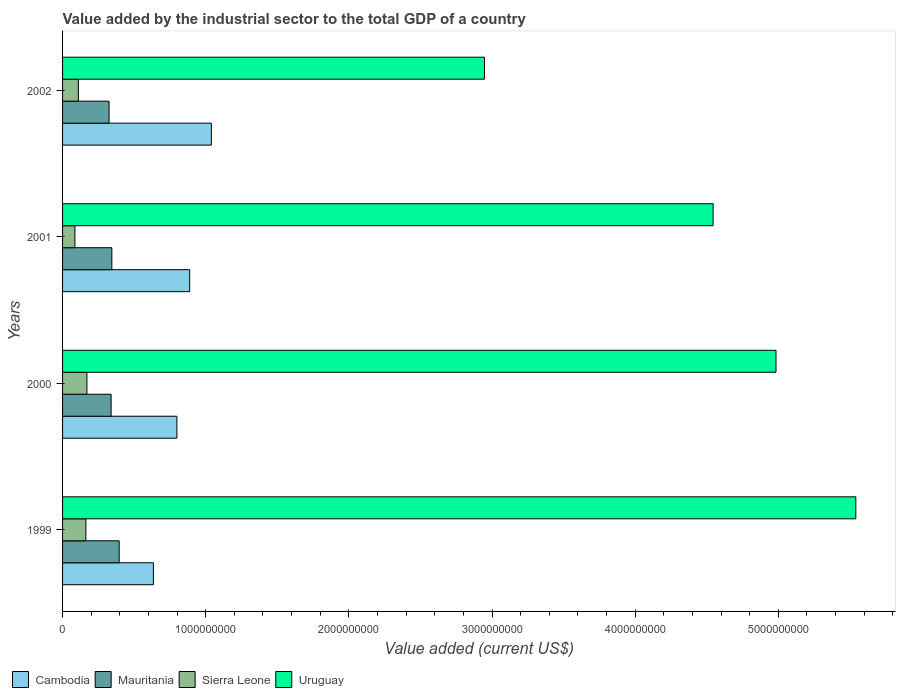How many bars are there on the 3rd tick from the bottom?
Your answer should be compact. 4. What is the label of the 1st group of bars from the top?
Offer a very short reply. 2002. In how many cases, is the number of bars for a given year not equal to the number of legend labels?
Keep it short and to the point. 0. What is the value added by the industrial sector to the total GDP in Sierra Leone in 1999?
Ensure brevity in your answer.  1.63e+08. Across all years, what is the maximum value added by the industrial sector to the total GDP in Cambodia?
Your answer should be compact. 1.04e+09. Across all years, what is the minimum value added by the industrial sector to the total GDP in Cambodia?
Make the answer very short. 6.35e+08. In which year was the value added by the industrial sector to the total GDP in Mauritania minimum?
Keep it short and to the point. 2002. What is the total value added by the industrial sector to the total GDP in Sierra Leone in the graph?
Keep it short and to the point. 5.29e+08. What is the difference between the value added by the industrial sector to the total GDP in Mauritania in 1999 and that in 2002?
Ensure brevity in your answer.  7.09e+07. What is the difference between the value added by the industrial sector to the total GDP in Mauritania in 1999 and the value added by the industrial sector to the total GDP in Uruguay in 2002?
Make the answer very short. -2.55e+09. What is the average value added by the industrial sector to the total GDP in Sierra Leone per year?
Offer a terse response. 1.32e+08. In the year 2002, what is the difference between the value added by the industrial sector to the total GDP in Mauritania and value added by the industrial sector to the total GDP in Uruguay?
Provide a short and direct response. -2.62e+09. What is the ratio of the value added by the industrial sector to the total GDP in Cambodia in 2001 to that in 2002?
Make the answer very short. 0.85. What is the difference between the highest and the second highest value added by the industrial sector to the total GDP in Uruguay?
Your response must be concise. 5.58e+08. What is the difference between the highest and the lowest value added by the industrial sector to the total GDP in Cambodia?
Your response must be concise. 4.05e+08. In how many years, is the value added by the industrial sector to the total GDP in Sierra Leone greater than the average value added by the industrial sector to the total GDP in Sierra Leone taken over all years?
Offer a terse response. 2. What does the 1st bar from the top in 2002 represents?
Your answer should be very brief. Uruguay. What does the 1st bar from the bottom in 2002 represents?
Offer a terse response. Cambodia. Is it the case that in every year, the sum of the value added by the industrial sector to the total GDP in Uruguay and value added by the industrial sector to the total GDP in Mauritania is greater than the value added by the industrial sector to the total GDP in Sierra Leone?
Give a very brief answer. Yes. How many bars are there?
Provide a succinct answer. 16. Are all the bars in the graph horizontal?
Keep it short and to the point. Yes. How many years are there in the graph?
Give a very brief answer. 4. Are the values on the major ticks of X-axis written in scientific E-notation?
Provide a succinct answer. No. Does the graph contain any zero values?
Keep it short and to the point. No. Does the graph contain grids?
Offer a very short reply. No. How are the legend labels stacked?
Your answer should be compact. Horizontal. What is the title of the graph?
Offer a very short reply. Value added by the industrial sector to the total GDP of a country. What is the label or title of the X-axis?
Make the answer very short. Value added (current US$). What is the Value added (current US$) of Cambodia in 1999?
Offer a very short reply. 6.35e+08. What is the Value added (current US$) in Mauritania in 1999?
Your answer should be compact. 3.96e+08. What is the Value added (current US$) of Sierra Leone in 1999?
Offer a very short reply. 1.63e+08. What is the Value added (current US$) in Uruguay in 1999?
Your answer should be very brief. 5.54e+09. What is the Value added (current US$) in Cambodia in 2000?
Offer a terse response. 7.99e+08. What is the Value added (current US$) of Mauritania in 2000?
Your answer should be compact. 3.39e+08. What is the Value added (current US$) of Sierra Leone in 2000?
Offer a very short reply. 1.70e+08. What is the Value added (current US$) in Uruguay in 2000?
Offer a very short reply. 4.98e+09. What is the Value added (current US$) in Cambodia in 2001?
Offer a terse response. 8.88e+08. What is the Value added (current US$) in Mauritania in 2001?
Your answer should be very brief. 3.44e+08. What is the Value added (current US$) in Sierra Leone in 2001?
Provide a short and direct response. 8.62e+07. What is the Value added (current US$) in Uruguay in 2001?
Your answer should be compact. 4.54e+09. What is the Value added (current US$) of Cambodia in 2002?
Offer a terse response. 1.04e+09. What is the Value added (current US$) of Mauritania in 2002?
Your response must be concise. 3.25e+08. What is the Value added (current US$) of Sierra Leone in 2002?
Your response must be concise. 1.10e+08. What is the Value added (current US$) in Uruguay in 2002?
Provide a short and direct response. 2.95e+09. Across all years, what is the maximum Value added (current US$) in Cambodia?
Ensure brevity in your answer.  1.04e+09. Across all years, what is the maximum Value added (current US$) in Mauritania?
Offer a very short reply. 3.96e+08. Across all years, what is the maximum Value added (current US$) in Sierra Leone?
Give a very brief answer. 1.70e+08. Across all years, what is the maximum Value added (current US$) in Uruguay?
Provide a succinct answer. 5.54e+09. Across all years, what is the minimum Value added (current US$) of Cambodia?
Your answer should be compact. 6.35e+08. Across all years, what is the minimum Value added (current US$) of Mauritania?
Offer a very short reply. 3.25e+08. Across all years, what is the minimum Value added (current US$) of Sierra Leone?
Your answer should be compact. 8.62e+07. Across all years, what is the minimum Value added (current US$) of Uruguay?
Your answer should be compact. 2.95e+09. What is the total Value added (current US$) of Cambodia in the graph?
Provide a succinct answer. 3.36e+09. What is the total Value added (current US$) in Mauritania in the graph?
Provide a succinct answer. 1.40e+09. What is the total Value added (current US$) of Sierra Leone in the graph?
Your answer should be compact. 5.29e+08. What is the total Value added (current US$) in Uruguay in the graph?
Offer a terse response. 1.80e+1. What is the difference between the Value added (current US$) in Cambodia in 1999 and that in 2000?
Your answer should be very brief. -1.64e+08. What is the difference between the Value added (current US$) of Mauritania in 1999 and that in 2000?
Give a very brief answer. 5.64e+07. What is the difference between the Value added (current US$) of Sierra Leone in 1999 and that in 2000?
Your response must be concise. -7.46e+06. What is the difference between the Value added (current US$) in Uruguay in 1999 and that in 2000?
Offer a very short reply. 5.58e+08. What is the difference between the Value added (current US$) of Cambodia in 1999 and that in 2001?
Your response must be concise. -2.53e+08. What is the difference between the Value added (current US$) of Mauritania in 1999 and that in 2001?
Offer a terse response. 5.13e+07. What is the difference between the Value added (current US$) of Sierra Leone in 1999 and that in 2001?
Provide a succinct answer. 7.65e+07. What is the difference between the Value added (current US$) in Uruguay in 1999 and that in 2001?
Your answer should be compact. 9.97e+08. What is the difference between the Value added (current US$) in Cambodia in 1999 and that in 2002?
Keep it short and to the point. -4.05e+08. What is the difference between the Value added (current US$) in Mauritania in 1999 and that in 2002?
Keep it short and to the point. 7.09e+07. What is the difference between the Value added (current US$) in Sierra Leone in 1999 and that in 2002?
Your answer should be compact. 5.23e+07. What is the difference between the Value added (current US$) of Uruguay in 1999 and that in 2002?
Offer a terse response. 2.59e+09. What is the difference between the Value added (current US$) of Cambodia in 2000 and that in 2001?
Make the answer very short. -8.93e+07. What is the difference between the Value added (current US$) of Mauritania in 2000 and that in 2001?
Provide a short and direct response. -5.12e+06. What is the difference between the Value added (current US$) in Sierra Leone in 2000 and that in 2001?
Make the answer very short. 8.39e+07. What is the difference between the Value added (current US$) in Uruguay in 2000 and that in 2001?
Your answer should be compact. 4.39e+08. What is the difference between the Value added (current US$) of Cambodia in 2000 and that in 2002?
Offer a terse response. -2.40e+08. What is the difference between the Value added (current US$) in Mauritania in 2000 and that in 2002?
Offer a terse response. 1.45e+07. What is the difference between the Value added (current US$) of Sierra Leone in 2000 and that in 2002?
Provide a short and direct response. 5.98e+07. What is the difference between the Value added (current US$) in Uruguay in 2000 and that in 2002?
Keep it short and to the point. 2.04e+09. What is the difference between the Value added (current US$) of Cambodia in 2001 and that in 2002?
Your answer should be very brief. -1.51e+08. What is the difference between the Value added (current US$) of Mauritania in 2001 and that in 2002?
Offer a terse response. 1.96e+07. What is the difference between the Value added (current US$) in Sierra Leone in 2001 and that in 2002?
Your answer should be compact. -2.42e+07. What is the difference between the Value added (current US$) in Uruguay in 2001 and that in 2002?
Your answer should be compact. 1.60e+09. What is the difference between the Value added (current US$) of Cambodia in 1999 and the Value added (current US$) of Mauritania in 2000?
Ensure brevity in your answer.  2.95e+08. What is the difference between the Value added (current US$) in Cambodia in 1999 and the Value added (current US$) in Sierra Leone in 2000?
Your answer should be very brief. 4.64e+08. What is the difference between the Value added (current US$) of Cambodia in 1999 and the Value added (current US$) of Uruguay in 2000?
Offer a terse response. -4.35e+09. What is the difference between the Value added (current US$) of Mauritania in 1999 and the Value added (current US$) of Sierra Leone in 2000?
Make the answer very short. 2.25e+08. What is the difference between the Value added (current US$) of Mauritania in 1999 and the Value added (current US$) of Uruguay in 2000?
Provide a short and direct response. -4.59e+09. What is the difference between the Value added (current US$) in Sierra Leone in 1999 and the Value added (current US$) in Uruguay in 2000?
Keep it short and to the point. -4.82e+09. What is the difference between the Value added (current US$) of Cambodia in 1999 and the Value added (current US$) of Mauritania in 2001?
Give a very brief answer. 2.90e+08. What is the difference between the Value added (current US$) of Cambodia in 1999 and the Value added (current US$) of Sierra Leone in 2001?
Your answer should be very brief. 5.48e+08. What is the difference between the Value added (current US$) in Cambodia in 1999 and the Value added (current US$) in Uruguay in 2001?
Your response must be concise. -3.91e+09. What is the difference between the Value added (current US$) in Mauritania in 1999 and the Value added (current US$) in Sierra Leone in 2001?
Your response must be concise. 3.09e+08. What is the difference between the Value added (current US$) of Mauritania in 1999 and the Value added (current US$) of Uruguay in 2001?
Keep it short and to the point. -4.15e+09. What is the difference between the Value added (current US$) of Sierra Leone in 1999 and the Value added (current US$) of Uruguay in 2001?
Offer a terse response. -4.38e+09. What is the difference between the Value added (current US$) of Cambodia in 1999 and the Value added (current US$) of Mauritania in 2002?
Your answer should be compact. 3.10e+08. What is the difference between the Value added (current US$) in Cambodia in 1999 and the Value added (current US$) in Sierra Leone in 2002?
Your response must be concise. 5.24e+08. What is the difference between the Value added (current US$) in Cambodia in 1999 and the Value added (current US$) in Uruguay in 2002?
Offer a very short reply. -2.31e+09. What is the difference between the Value added (current US$) of Mauritania in 1999 and the Value added (current US$) of Sierra Leone in 2002?
Offer a very short reply. 2.85e+08. What is the difference between the Value added (current US$) in Mauritania in 1999 and the Value added (current US$) in Uruguay in 2002?
Provide a short and direct response. -2.55e+09. What is the difference between the Value added (current US$) of Sierra Leone in 1999 and the Value added (current US$) of Uruguay in 2002?
Provide a short and direct response. -2.78e+09. What is the difference between the Value added (current US$) of Cambodia in 2000 and the Value added (current US$) of Mauritania in 2001?
Your response must be concise. 4.54e+08. What is the difference between the Value added (current US$) in Cambodia in 2000 and the Value added (current US$) in Sierra Leone in 2001?
Keep it short and to the point. 7.12e+08. What is the difference between the Value added (current US$) of Cambodia in 2000 and the Value added (current US$) of Uruguay in 2001?
Make the answer very short. -3.75e+09. What is the difference between the Value added (current US$) in Mauritania in 2000 and the Value added (current US$) in Sierra Leone in 2001?
Your answer should be very brief. 2.53e+08. What is the difference between the Value added (current US$) in Mauritania in 2000 and the Value added (current US$) in Uruguay in 2001?
Keep it short and to the point. -4.21e+09. What is the difference between the Value added (current US$) in Sierra Leone in 2000 and the Value added (current US$) in Uruguay in 2001?
Your answer should be compact. -4.37e+09. What is the difference between the Value added (current US$) of Cambodia in 2000 and the Value added (current US$) of Mauritania in 2002?
Ensure brevity in your answer.  4.74e+08. What is the difference between the Value added (current US$) of Cambodia in 2000 and the Value added (current US$) of Sierra Leone in 2002?
Offer a terse response. 6.88e+08. What is the difference between the Value added (current US$) of Cambodia in 2000 and the Value added (current US$) of Uruguay in 2002?
Ensure brevity in your answer.  -2.15e+09. What is the difference between the Value added (current US$) in Mauritania in 2000 and the Value added (current US$) in Sierra Leone in 2002?
Your response must be concise. 2.29e+08. What is the difference between the Value added (current US$) of Mauritania in 2000 and the Value added (current US$) of Uruguay in 2002?
Give a very brief answer. -2.61e+09. What is the difference between the Value added (current US$) in Sierra Leone in 2000 and the Value added (current US$) in Uruguay in 2002?
Give a very brief answer. -2.78e+09. What is the difference between the Value added (current US$) of Cambodia in 2001 and the Value added (current US$) of Mauritania in 2002?
Your answer should be compact. 5.63e+08. What is the difference between the Value added (current US$) in Cambodia in 2001 and the Value added (current US$) in Sierra Leone in 2002?
Your response must be concise. 7.78e+08. What is the difference between the Value added (current US$) of Cambodia in 2001 and the Value added (current US$) of Uruguay in 2002?
Offer a very short reply. -2.06e+09. What is the difference between the Value added (current US$) in Mauritania in 2001 and the Value added (current US$) in Sierra Leone in 2002?
Ensure brevity in your answer.  2.34e+08. What is the difference between the Value added (current US$) of Mauritania in 2001 and the Value added (current US$) of Uruguay in 2002?
Your answer should be very brief. -2.60e+09. What is the difference between the Value added (current US$) of Sierra Leone in 2001 and the Value added (current US$) of Uruguay in 2002?
Your answer should be compact. -2.86e+09. What is the average Value added (current US$) in Cambodia per year?
Offer a very short reply. 8.40e+08. What is the average Value added (current US$) in Mauritania per year?
Offer a terse response. 3.51e+08. What is the average Value added (current US$) in Sierra Leone per year?
Offer a terse response. 1.32e+08. What is the average Value added (current US$) of Uruguay per year?
Offer a terse response. 4.50e+09. In the year 1999, what is the difference between the Value added (current US$) in Cambodia and Value added (current US$) in Mauritania?
Make the answer very short. 2.39e+08. In the year 1999, what is the difference between the Value added (current US$) of Cambodia and Value added (current US$) of Sierra Leone?
Keep it short and to the point. 4.72e+08. In the year 1999, what is the difference between the Value added (current US$) in Cambodia and Value added (current US$) in Uruguay?
Your answer should be very brief. -4.91e+09. In the year 1999, what is the difference between the Value added (current US$) in Mauritania and Value added (current US$) in Sierra Leone?
Make the answer very short. 2.33e+08. In the year 1999, what is the difference between the Value added (current US$) in Mauritania and Value added (current US$) in Uruguay?
Your answer should be compact. -5.15e+09. In the year 1999, what is the difference between the Value added (current US$) in Sierra Leone and Value added (current US$) in Uruguay?
Give a very brief answer. -5.38e+09. In the year 2000, what is the difference between the Value added (current US$) in Cambodia and Value added (current US$) in Mauritania?
Provide a short and direct response. 4.60e+08. In the year 2000, what is the difference between the Value added (current US$) of Cambodia and Value added (current US$) of Sierra Leone?
Keep it short and to the point. 6.28e+08. In the year 2000, what is the difference between the Value added (current US$) of Cambodia and Value added (current US$) of Uruguay?
Offer a terse response. -4.18e+09. In the year 2000, what is the difference between the Value added (current US$) in Mauritania and Value added (current US$) in Sierra Leone?
Your answer should be compact. 1.69e+08. In the year 2000, what is the difference between the Value added (current US$) of Mauritania and Value added (current US$) of Uruguay?
Provide a short and direct response. -4.64e+09. In the year 2000, what is the difference between the Value added (current US$) in Sierra Leone and Value added (current US$) in Uruguay?
Give a very brief answer. -4.81e+09. In the year 2001, what is the difference between the Value added (current US$) in Cambodia and Value added (current US$) in Mauritania?
Offer a terse response. 5.44e+08. In the year 2001, what is the difference between the Value added (current US$) of Cambodia and Value added (current US$) of Sierra Leone?
Provide a short and direct response. 8.02e+08. In the year 2001, what is the difference between the Value added (current US$) of Cambodia and Value added (current US$) of Uruguay?
Keep it short and to the point. -3.66e+09. In the year 2001, what is the difference between the Value added (current US$) of Mauritania and Value added (current US$) of Sierra Leone?
Provide a succinct answer. 2.58e+08. In the year 2001, what is the difference between the Value added (current US$) in Mauritania and Value added (current US$) in Uruguay?
Your response must be concise. -4.20e+09. In the year 2001, what is the difference between the Value added (current US$) of Sierra Leone and Value added (current US$) of Uruguay?
Offer a terse response. -4.46e+09. In the year 2002, what is the difference between the Value added (current US$) in Cambodia and Value added (current US$) in Mauritania?
Offer a terse response. 7.14e+08. In the year 2002, what is the difference between the Value added (current US$) in Cambodia and Value added (current US$) in Sierra Leone?
Your response must be concise. 9.29e+08. In the year 2002, what is the difference between the Value added (current US$) in Cambodia and Value added (current US$) in Uruguay?
Your answer should be compact. -1.91e+09. In the year 2002, what is the difference between the Value added (current US$) of Mauritania and Value added (current US$) of Sierra Leone?
Provide a short and direct response. 2.14e+08. In the year 2002, what is the difference between the Value added (current US$) of Mauritania and Value added (current US$) of Uruguay?
Ensure brevity in your answer.  -2.62e+09. In the year 2002, what is the difference between the Value added (current US$) in Sierra Leone and Value added (current US$) in Uruguay?
Your answer should be very brief. -2.84e+09. What is the ratio of the Value added (current US$) in Cambodia in 1999 to that in 2000?
Your answer should be compact. 0.79. What is the ratio of the Value added (current US$) of Mauritania in 1999 to that in 2000?
Offer a very short reply. 1.17. What is the ratio of the Value added (current US$) of Sierra Leone in 1999 to that in 2000?
Give a very brief answer. 0.96. What is the ratio of the Value added (current US$) in Uruguay in 1999 to that in 2000?
Provide a short and direct response. 1.11. What is the ratio of the Value added (current US$) of Cambodia in 1999 to that in 2001?
Your answer should be compact. 0.71. What is the ratio of the Value added (current US$) in Mauritania in 1999 to that in 2001?
Provide a succinct answer. 1.15. What is the ratio of the Value added (current US$) of Sierra Leone in 1999 to that in 2001?
Provide a succinct answer. 1.89. What is the ratio of the Value added (current US$) of Uruguay in 1999 to that in 2001?
Provide a short and direct response. 1.22. What is the ratio of the Value added (current US$) of Cambodia in 1999 to that in 2002?
Your response must be concise. 0.61. What is the ratio of the Value added (current US$) of Mauritania in 1999 to that in 2002?
Keep it short and to the point. 1.22. What is the ratio of the Value added (current US$) in Sierra Leone in 1999 to that in 2002?
Your response must be concise. 1.47. What is the ratio of the Value added (current US$) of Uruguay in 1999 to that in 2002?
Your response must be concise. 1.88. What is the ratio of the Value added (current US$) of Cambodia in 2000 to that in 2001?
Provide a succinct answer. 0.9. What is the ratio of the Value added (current US$) in Mauritania in 2000 to that in 2001?
Ensure brevity in your answer.  0.99. What is the ratio of the Value added (current US$) of Sierra Leone in 2000 to that in 2001?
Make the answer very short. 1.97. What is the ratio of the Value added (current US$) of Uruguay in 2000 to that in 2001?
Make the answer very short. 1.1. What is the ratio of the Value added (current US$) of Cambodia in 2000 to that in 2002?
Your answer should be compact. 0.77. What is the ratio of the Value added (current US$) in Mauritania in 2000 to that in 2002?
Provide a short and direct response. 1.04. What is the ratio of the Value added (current US$) in Sierra Leone in 2000 to that in 2002?
Offer a very short reply. 1.54. What is the ratio of the Value added (current US$) of Uruguay in 2000 to that in 2002?
Offer a very short reply. 1.69. What is the ratio of the Value added (current US$) of Cambodia in 2001 to that in 2002?
Your answer should be very brief. 0.85. What is the ratio of the Value added (current US$) of Mauritania in 2001 to that in 2002?
Your answer should be very brief. 1.06. What is the ratio of the Value added (current US$) in Sierra Leone in 2001 to that in 2002?
Give a very brief answer. 0.78. What is the ratio of the Value added (current US$) of Uruguay in 2001 to that in 2002?
Offer a very short reply. 1.54. What is the difference between the highest and the second highest Value added (current US$) in Cambodia?
Provide a short and direct response. 1.51e+08. What is the difference between the highest and the second highest Value added (current US$) in Mauritania?
Your answer should be very brief. 5.13e+07. What is the difference between the highest and the second highest Value added (current US$) of Sierra Leone?
Your answer should be very brief. 7.46e+06. What is the difference between the highest and the second highest Value added (current US$) in Uruguay?
Provide a succinct answer. 5.58e+08. What is the difference between the highest and the lowest Value added (current US$) of Cambodia?
Provide a succinct answer. 4.05e+08. What is the difference between the highest and the lowest Value added (current US$) in Mauritania?
Give a very brief answer. 7.09e+07. What is the difference between the highest and the lowest Value added (current US$) in Sierra Leone?
Your response must be concise. 8.39e+07. What is the difference between the highest and the lowest Value added (current US$) in Uruguay?
Your answer should be compact. 2.59e+09. 